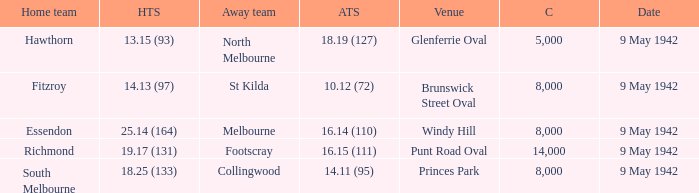How large was the crowd with a home team score of 18.25 (133)? 8000.0. 